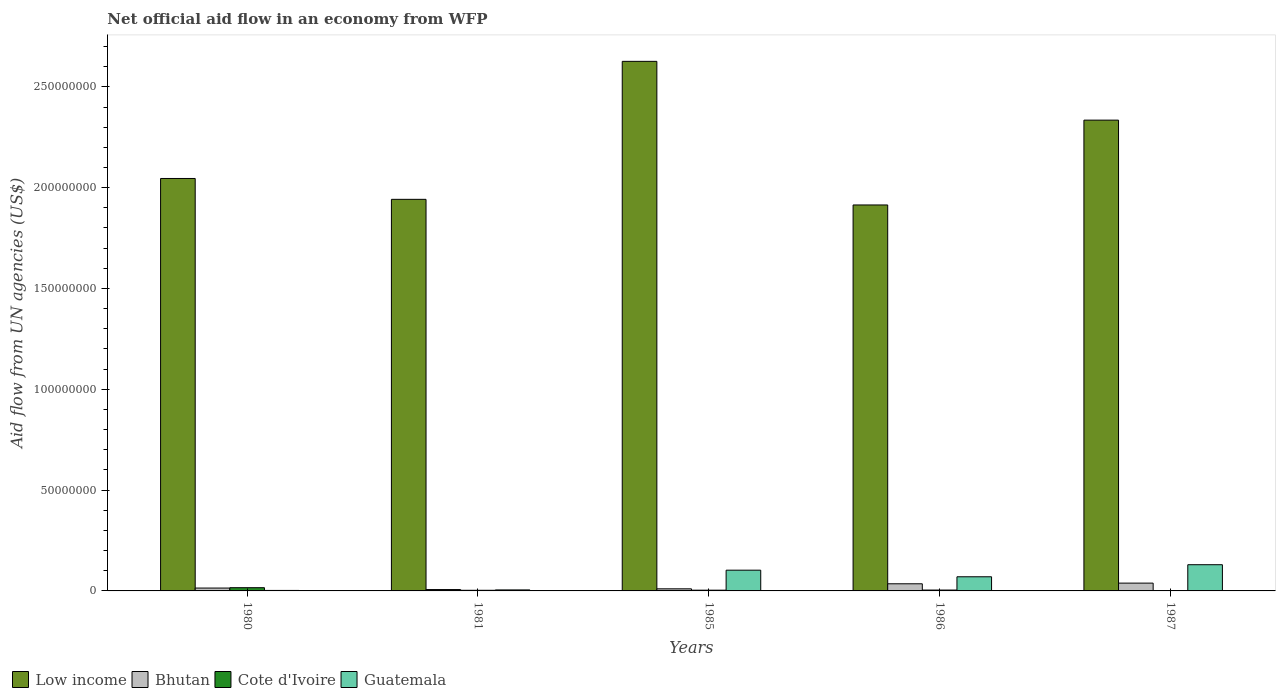Are the number of bars per tick equal to the number of legend labels?
Ensure brevity in your answer.  Yes. Are the number of bars on each tick of the X-axis equal?
Ensure brevity in your answer.  Yes. How many bars are there on the 5th tick from the left?
Your answer should be compact. 4. In how many cases, is the number of bars for a given year not equal to the number of legend labels?
Make the answer very short. 0. What is the net official aid flow in Guatemala in 1985?
Ensure brevity in your answer.  1.03e+07. Across all years, what is the maximum net official aid flow in Bhutan?
Make the answer very short. 3.87e+06. Across all years, what is the minimum net official aid flow in Bhutan?
Your response must be concise. 6.80e+05. In which year was the net official aid flow in Bhutan maximum?
Keep it short and to the point. 1987. In which year was the net official aid flow in Bhutan minimum?
Make the answer very short. 1981. What is the total net official aid flow in Low income in the graph?
Provide a succinct answer. 1.09e+09. What is the difference between the net official aid flow in Guatemala in 1986 and that in 1987?
Provide a short and direct response. -5.98e+06. What is the difference between the net official aid flow in Guatemala in 1981 and the net official aid flow in Bhutan in 1980?
Give a very brief answer. -9.20e+05. What is the average net official aid flow in Cote d'Ivoire per year?
Offer a terse response. 5.54e+05. In the year 1981, what is the difference between the net official aid flow in Guatemala and net official aid flow in Cote d'Ivoire?
Ensure brevity in your answer.  1.90e+05. What is the ratio of the net official aid flow in Cote d'Ivoire in 1980 to that in 1981?
Your answer should be compact. 5.16. Is the difference between the net official aid flow in Guatemala in 1986 and 1987 greater than the difference between the net official aid flow in Cote d'Ivoire in 1986 and 1987?
Make the answer very short. No. What is the difference between the highest and the second highest net official aid flow in Bhutan?
Offer a terse response. 3.30e+05. What is the difference between the highest and the lowest net official aid flow in Low income?
Make the answer very short. 7.12e+07. In how many years, is the net official aid flow in Bhutan greater than the average net official aid flow in Bhutan taken over all years?
Keep it short and to the point. 2. Is the sum of the net official aid flow in Cote d'Ivoire in 1985 and 1986 greater than the maximum net official aid flow in Bhutan across all years?
Provide a short and direct response. No. What does the 2nd bar from the left in 1986 represents?
Your response must be concise. Bhutan. What does the 1st bar from the right in 1980 represents?
Your answer should be very brief. Guatemala. Is it the case that in every year, the sum of the net official aid flow in Bhutan and net official aid flow in Guatemala is greater than the net official aid flow in Low income?
Your response must be concise. No. How many bars are there?
Your response must be concise. 20. Are all the bars in the graph horizontal?
Your answer should be compact. No. Does the graph contain any zero values?
Make the answer very short. No. What is the title of the graph?
Your response must be concise. Net official aid flow in an economy from WFP. Does "Isle of Man" appear as one of the legend labels in the graph?
Make the answer very short. No. What is the label or title of the X-axis?
Your answer should be compact. Years. What is the label or title of the Y-axis?
Your response must be concise. Aid flow from UN agencies (US$). What is the Aid flow from UN agencies (US$) in Low income in 1980?
Make the answer very short. 2.05e+08. What is the Aid flow from UN agencies (US$) in Bhutan in 1980?
Keep it short and to the point. 1.42e+06. What is the Aid flow from UN agencies (US$) in Cote d'Ivoire in 1980?
Provide a short and direct response. 1.60e+06. What is the Aid flow from UN agencies (US$) in Guatemala in 1980?
Ensure brevity in your answer.  2.40e+05. What is the Aid flow from UN agencies (US$) in Low income in 1981?
Provide a short and direct response. 1.94e+08. What is the Aid flow from UN agencies (US$) in Bhutan in 1981?
Offer a very short reply. 6.80e+05. What is the Aid flow from UN agencies (US$) of Cote d'Ivoire in 1981?
Give a very brief answer. 3.10e+05. What is the Aid flow from UN agencies (US$) of Low income in 1985?
Make the answer very short. 2.63e+08. What is the Aid flow from UN agencies (US$) of Bhutan in 1985?
Offer a terse response. 1.04e+06. What is the Aid flow from UN agencies (US$) in Cote d'Ivoire in 1985?
Make the answer very short. 3.70e+05. What is the Aid flow from UN agencies (US$) in Guatemala in 1985?
Keep it short and to the point. 1.03e+07. What is the Aid flow from UN agencies (US$) of Low income in 1986?
Ensure brevity in your answer.  1.91e+08. What is the Aid flow from UN agencies (US$) of Bhutan in 1986?
Your answer should be compact. 3.54e+06. What is the Aid flow from UN agencies (US$) in Guatemala in 1986?
Your response must be concise. 7.02e+06. What is the Aid flow from UN agencies (US$) in Low income in 1987?
Give a very brief answer. 2.33e+08. What is the Aid flow from UN agencies (US$) of Bhutan in 1987?
Provide a succinct answer. 3.87e+06. What is the Aid flow from UN agencies (US$) of Cote d'Ivoire in 1987?
Offer a terse response. 6.00e+04. What is the Aid flow from UN agencies (US$) in Guatemala in 1987?
Offer a very short reply. 1.30e+07. Across all years, what is the maximum Aid flow from UN agencies (US$) in Low income?
Your answer should be compact. 2.63e+08. Across all years, what is the maximum Aid flow from UN agencies (US$) in Bhutan?
Provide a succinct answer. 3.87e+06. Across all years, what is the maximum Aid flow from UN agencies (US$) in Cote d'Ivoire?
Offer a terse response. 1.60e+06. Across all years, what is the maximum Aid flow from UN agencies (US$) in Guatemala?
Ensure brevity in your answer.  1.30e+07. Across all years, what is the minimum Aid flow from UN agencies (US$) of Low income?
Give a very brief answer. 1.91e+08. Across all years, what is the minimum Aid flow from UN agencies (US$) in Bhutan?
Ensure brevity in your answer.  6.80e+05. What is the total Aid flow from UN agencies (US$) of Low income in the graph?
Give a very brief answer. 1.09e+09. What is the total Aid flow from UN agencies (US$) of Bhutan in the graph?
Your response must be concise. 1.06e+07. What is the total Aid flow from UN agencies (US$) of Cote d'Ivoire in the graph?
Offer a terse response. 2.77e+06. What is the total Aid flow from UN agencies (US$) in Guatemala in the graph?
Give a very brief answer. 3.10e+07. What is the difference between the Aid flow from UN agencies (US$) in Low income in 1980 and that in 1981?
Give a very brief answer. 1.03e+07. What is the difference between the Aid flow from UN agencies (US$) of Bhutan in 1980 and that in 1981?
Ensure brevity in your answer.  7.40e+05. What is the difference between the Aid flow from UN agencies (US$) of Cote d'Ivoire in 1980 and that in 1981?
Keep it short and to the point. 1.29e+06. What is the difference between the Aid flow from UN agencies (US$) of Low income in 1980 and that in 1985?
Give a very brief answer. -5.81e+07. What is the difference between the Aid flow from UN agencies (US$) of Cote d'Ivoire in 1980 and that in 1985?
Your answer should be very brief. 1.23e+06. What is the difference between the Aid flow from UN agencies (US$) in Guatemala in 1980 and that in 1985?
Offer a very short reply. -1.00e+07. What is the difference between the Aid flow from UN agencies (US$) in Low income in 1980 and that in 1986?
Your answer should be compact. 1.31e+07. What is the difference between the Aid flow from UN agencies (US$) of Bhutan in 1980 and that in 1986?
Provide a succinct answer. -2.12e+06. What is the difference between the Aid flow from UN agencies (US$) in Cote d'Ivoire in 1980 and that in 1986?
Make the answer very short. 1.17e+06. What is the difference between the Aid flow from UN agencies (US$) in Guatemala in 1980 and that in 1986?
Your response must be concise. -6.78e+06. What is the difference between the Aid flow from UN agencies (US$) of Low income in 1980 and that in 1987?
Your response must be concise. -2.89e+07. What is the difference between the Aid flow from UN agencies (US$) in Bhutan in 1980 and that in 1987?
Your answer should be very brief. -2.45e+06. What is the difference between the Aid flow from UN agencies (US$) of Cote d'Ivoire in 1980 and that in 1987?
Give a very brief answer. 1.54e+06. What is the difference between the Aid flow from UN agencies (US$) in Guatemala in 1980 and that in 1987?
Offer a very short reply. -1.28e+07. What is the difference between the Aid flow from UN agencies (US$) of Low income in 1981 and that in 1985?
Give a very brief answer. -6.84e+07. What is the difference between the Aid flow from UN agencies (US$) in Bhutan in 1981 and that in 1985?
Make the answer very short. -3.60e+05. What is the difference between the Aid flow from UN agencies (US$) of Guatemala in 1981 and that in 1985?
Keep it short and to the point. -9.79e+06. What is the difference between the Aid flow from UN agencies (US$) of Low income in 1981 and that in 1986?
Keep it short and to the point. 2.79e+06. What is the difference between the Aid flow from UN agencies (US$) in Bhutan in 1981 and that in 1986?
Provide a succinct answer. -2.86e+06. What is the difference between the Aid flow from UN agencies (US$) in Guatemala in 1981 and that in 1986?
Make the answer very short. -6.52e+06. What is the difference between the Aid flow from UN agencies (US$) of Low income in 1981 and that in 1987?
Give a very brief answer. -3.93e+07. What is the difference between the Aid flow from UN agencies (US$) of Bhutan in 1981 and that in 1987?
Your answer should be very brief. -3.19e+06. What is the difference between the Aid flow from UN agencies (US$) of Cote d'Ivoire in 1981 and that in 1987?
Give a very brief answer. 2.50e+05. What is the difference between the Aid flow from UN agencies (US$) in Guatemala in 1981 and that in 1987?
Ensure brevity in your answer.  -1.25e+07. What is the difference between the Aid flow from UN agencies (US$) in Low income in 1985 and that in 1986?
Give a very brief answer. 7.12e+07. What is the difference between the Aid flow from UN agencies (US$) in Bhutan in 1985 and that in 1986?
Offer a terse response. -2.50e+06. What is the difference between the Aid flow from UN agencies (US$) of Guatemala in 1985 and that in 1986?
Provide a succinct answer. 3.27e+06. What is the difference between the Aid flow from UN agencies (US$) of Low income in 1985 and that in 1987?
Ensure brevity in your answer.  2.92e+07. What is the difference between the Aid flow from UN agencies (US$) in Bhutan in 1985 and that in 1987?
Give a very brief answer. -2.83e+06. What is the difference between the Aid flow from UN agencies (US$) of Guatemala in 1985 and that in 1987?
Your response must be concise. -2.71e+06. What is the difference between the Aid flow from UN agencies (US$) in Low income in 1986 and that in 1987?
Offer a terse response. -4.21e+07. What is the difference between the Aid flow from UN agencies (US$) in Bhutan in 1986 and that in 1987?
Provide a short and direct response. -3.30e+05. What is the difference between the Aid flow from UN agencies (US$) in Guatemala in 1986 and that in 1987?
Provide a succinct answer. -5.98e+06. What is the difference between the Aid flow from UN agencies (US$) of Low income in 1980 and the Aid flow from UN agencies (US$) of Bhutan in 1981?
Make the answer very short. 2.04e+08. What is the difference between the Aid flow from UN agencies (US$) in Low income in 1980 and the Aid flow from UN agencies (US$) in Cote d'Ivoire in 1981?
Offer a terse response. 2.04e+08. What is the difference between the Aid flow from UN agencies (US$) of Low income in 1980 and the Aid flow from UN agencies (US$) of Guatemala in 1981?
Give a very brief answer. 2.04e+08. What is the difference between the Aid flow from UN agencies (US$) of Bhutan in 1980 and the Aid flow from UN agencies (US$) of Cote d'Ivoire in 1981?
Your answer should be compact. 1.11e+06. What is the difference between the Aid flow from UN agencies (US$) in Bhutan in 1980 and the Aid flow from UN agencies (US$) in Guatemala in 1981?
Provide a succinct answer. 9.20e+05. What is the difference between the Aid flow from UN agencies (US$) in Cote d'Ivoire in 1980 and the Aid flow from UN agencies (US$) in Guatemala in 1981?
Your answer should be very brief. 1.10e+06. What is the difference between the Aid flow from UN agencies (US$) of Low income in 1980 and the Aid flow from UN agencies (US$) of Bhutan in 1985?
Make the answer very short. 2.04e+08. What is the difference between the Aid flow from UN agencies (US$) in Low income in 1980 and the Aid flow from UN agencies (US$) in Cote d'Ivoire in 1985?
Provide a short and direct response. 2.04e+08. What is the difference between the Aid flow from UN agencies (US$) of Low income in 1980 and the Aid flow from UN agencies (US$) of Guatemala in 1985?
Offer a terse response. 1.94e+08. What is the difference between the Aid flow from UN agencies (US$) of Bhutan in 1980 and the Aid flow from UN agencies (US$) of Cote d'Ivoire in 1985?
Give a very brief answer. 1.05e+06. What is the difference between the Aid flow from UN agencies (US$) of Bhutan in 1980 and the Aid flow from UN agencies (US$) of Guatemala in 1985?
Offer a terse response. -8.87e+06. What is the difference between the Aid flow from UN agencies (US$) of Cote d'Ivoire in 1980 and the Aid flow from UN agencies (US$) of Guatemala in 1985?
Your response must be concise. -8.69e+06. What is the difference between the Aid flow from UN agencies (US$) in Low income in 1980 and the Aid flow from UN agencies (US$) in Bhutan in 1986?
Your response must be concise. 2.01e+08. What is the difference between the Aid flow from UN agencies (US$) in Low income in 1980 and the Aid flow from UN agencies (US$) in Cote d'Ivoire in 1986?
Offer a very short reply. 2.04e+08. What is the difference between the Aid flow from UN agencies (US$) in Low income in 1980 and the Aid flow from UN agencies (US$) in Guatemala in 1986?
Offer a terse response. 1.98e+08. What is the difference between the Aid flow from UN agencies (US$) in Bhutan in 1980 and the Aid flow from UN agencies (US$) in Cote d'Ivoire in 1986?
Your response must be concise. 9.90e+05. What is the difference between the Aid flow from UN agencies (US$) of Bhutan in 1980 and the Aid flow from UN agencies (US$) of Guatemala in 1986?
Provide a succinct answer. -5.60e+06. What is the difference between the Aid flow from UN agencies (US$) in Cote d'Ivoire in 1980 and the Aid flow from UN agencies (US$) in Guatemala in 1986?
Provide a short and direct response. -5.42e+06. What is the difference between the Aid flow from UN agencies (US$) of Low income in 1980 and the Aid flow from UN agencies (US$) of Bhutan in 1987?
Provide a succinct answer. 2.01e+08. What is the difference between the Aid flow from UN agencies (US$) in Low income in 1980 and the Aid flow from UN agencies (US$) in Cote d'Ivoire in 1987?
Offer a very short reply. 2.04e+08. What is the difference between the Aid flow from UN agencies (US$) in Low income in 1980 and the Aid flow from UN agencies (US$) in Guatemala in 1987?
Ensure brevity in your answer.  1.92e+08. What is the difference between the Aid flow from UN agencies (US$) in Bhutan in 1980 and the Aid flow from UN agencies (US$) in Cote d'Ivoire in 1987?
Offer a terse response. 1.36e+06. What is the difference between the Aid flow from UN agencies (US$) in Bhutan in 1980 and the Aid flow from UN agencies (US$) in Guatemala in 1987?
Make the answer very short. -1.16e+07. What is the difference between the Aid flow from UN agencies (US$) of Cote d'Ivoire in 1980 and the Aid flow from UN agencies (US$) of Guatemala in 1987?
Make the answer very short. -1.14e+07. What is the difference between the Aid flow from UN agencies (US$) of Low income in 1981 and the Aid flow from UN agencies (US$) of Bhutan in 1985?
Make the answer very short. 1.93e+08. What is the difference between the Aid flow from UN agencies (US$) in Low income in 1981 and the Aid flow from UN agencies (US$) in Cote d'Ivoire in 1985?
Offer a very short reply. 1.94e+08. What is the difference between the Aid flow from UN agencies (US$) of Low income in 1981 and the Aid flow from UN agencies (US$) of Guatemala in 1985?
Make the answer very short. 1.84e+08. What is the difference between the Aid flow from UN agencies (US$) of Bhutan in 1981 and the Aid flow from UN agencies (US$) of Guatemala in 1985?
Your answer should be compact. -9.61e+06. What is the difference between the Aid flow from UN agencies (US$) of Cote d'Ivoire in 1981 and the Aid flow from UN agencies (US$) of Guatemala in 1985?
Your response must be concise. -9.98e+06. What is the difference between the Aid flow from UN agencies (US$) in Low income in 1981 and the Aid flow from UN agencies (US$) in Bhutan in 1986?
Ensure brevity in your answer.  1.91e+08. What is the difference between the Aid flow from UN agencies (US$) in Low income in 1981 and the Aid flow from UN agencies (US$) in Cote d'Ivoire in 1986?
Make the answer very short. 1.94e+08. What is the difference between the Aid flow from UN agencies (US$) of Low income in 1981 and the Aid flow from UN agencies (US$) of Guatemala in 1986?
Provide a succinct answer. 1.87e+08. What is the difference between the Aid flow from UN agencies (US$) of Bhutan in 1981 and the Aid flow from UN agencies (US$) of Cote d'Ivoire in 1986?
Ensure brevity in your answer.  2.50e+05. What is the difference between the Aid flow from UN agencies (US$) in Bhutan in 1981 and the Aid flow from UN agencies (US$) in Guatemala in 1986?
Provide a succinct answer. -6.34e+06. What is the difference between the Aid flow from UN agencies (US$) in Cote d'Ivoire in 1981 and the Aid flow from UN agencies (US$) in Guatemala in 1986?
Offer a very short reply. -6.71e+06. What is the difference between the Aid flow from UN agencies (US$) in Low income in 1981 and the Aid flow from UN agencies (US$) in Bhutan in 1987?
Your answer should be very brief. 1.90e+08. What is the difference between the Aid flow from UN agencies (US$) in Low income in 1981 and the Aid flow from UN agencies (US$) in Cote d'Ivoire in 1987?
Provide a short and direct response. 1.94e+08. What is the difference between the Aid flow from UN agencies (US$) of Low income in 1981 and the Aid flow from UN agencies (US$) of Guatemala in 1987?
Your answer should be compact. 1.81e+08. What is the difference between the Aid flow from UN agencies (US$) of Bhutan in 1981 and the Aid flow from UN agencies (US$) of Cote d'Ivoire in 1987?
Your answer should be compact. 6.20e+05. What is the difference between the Aid flow from UN agencies (US$) in Bhutan in 1981 and the Aid flow from UN agencies (US$) in Guatemala in 1987?
Offer a terse response. -1.23e+07. What is the difference between the Aid flow from UN agencies (US$) in Cote d'Ivoire in 1981 and the Aid flow from UN agencies (US$) in Guatemala in 1987?
Your answer should be compact. -1.27e+07. What is the difference between the Aid flow from UN agencies (US$) in Low income in 1985 and the Aid flow from UN agencies (US$) in Bhutan in 1986?
Your answer should be very brief. 2.59e+08. What is the difference between the Aid flow from UN agencies (US$) in Low income in 1985 and the Aid flow from UN agencies (US$) in Cote d'Ivoire in 1986?
Ensure brevity in your answer.  2.62e+08. What is the difference between the Aid flow from UN agencies (US$) of Low income in 1985 and the Aid flow from UN agencies (US$) of Guatemala in 1986?
Give a very brief answer. 2.56e+08. What is the difference between the Aid flow from UN agencies (US$) of Bhutan in 1985 and the Aid flow from UN agencies (US$) of Cote d'Ivoire in 1986?
Make the answer very short. 6.10e+05. What is the difference between the Aid flow from UN agencies (US$) in Bhutan in 1985 and the Aid flow from UN agencies (US$) in Guatemala in 1986?
Your answer should be very brief. -5.98e+06. What is the difference between the Aid flow from UN agencies (US$) of Cote d'Ivoire in 1985 and the Aid flow from UN agencies (US$) of Guatemala in 1986?
Provide a succinct answer. -6.65e+06. What is the difference between the Aid flow from UN agencies (US$) of Low income in 1985 and the Aid flow from UN agencies (US$) of Bhutan in 1987?
Provide a succinct answer. 2.59e+08. What is the difference between the Aid flow from UN agencies (US$) in Low income in 1985 and the Aid flow from UN agencies (US$) in Cote d'Ivoire in 1987?
Your answer should be very brief. 2.63e+08. What is the difference between the Aid flow from UN agencies (US$) in Low income in 1985 and the Aid flow from UN agencies (US$) in Guatemala in 1987?
Your answer should be compact. 2.50e+08. What is the difference between the Aid flow from UN agencies (US$) in Bhutan in 1985 and the Aid flow from UN agencies (US$) in Cote d'Ivoire in 1987?
Offer a very short reply. 9.80e+05. What is the difference between the Aid flow from UN agencies (US$) of Bhutan in 1985 and the Aid flow from UN agencies (US$) of Guatemala in 1987?
Give a very brief answer. -1.20e+07. What is the difference between the Aid flow from UN agencies (US$) of Cote d'Ivoire in 1985 and the Aid flow from UN agencies (US$) of Guatemala in 1987?
Provide a succinct answer. -1.26e+07. What is the difference between the Aid flow from UN agencies (US$) of Low income in 1986 and the Aid flow from UN agencies (US$) of Bhutan in 1987?
Offer a very short reply. 1.88e+08. What is the difference between the Aid flow from UN agencies (US$) in Low income in 1986 and the Aid flow from UN agencies (US$) in Cote d'Ivoire in 1987?
Make the answer very short. 1.91e+08. What is the difference between the Aid flow from UN agencies (US$) of Low income in 1986 and the Aid flow from UN agencies (US$) of Guatemala in 1987?
Give a very brief answer. 1.78e+08. What is the difference between the Aid flow from UN agencies (US$) in Bhutan in 1986 and the Aid flow from UN agencies (US$) in Cote d'Ivoire in 1987?
Keep it short and to the point. 3.48e+06. What is the difference between the Aid flow from UN agencies (US$) of Bhutan in 1986 and the Aid flow from UN agencies (US$) of Guatemala in 1987?
Provide a succinct answer. -9.46e+06. What is the difference between the Aid flow from UN agencies (US$) of Cote d'Ivoire in 1986 and the Aid flow from UN agencies (US$) of Guatemala in 1987?
Give a very brief answer. -1.26e+07. What is the average Aid flow from UN agencies (US$) of Low income per year?
Offer a very short reply. 2.17e+08. What is the average Aid flow from UN agencies (US$) in Bhutan per year?
Give a very brief answer. 2.11e+06. What is the average Aid flow from UN agencies (US$) in Cote d'Ivoire per year?
Give a very brief answer. 5.54e+05. What is the average Aid flow from UN agencies (US$) of Guatemala per year?
Give a very brief answer. 6.21e+06. In the year 1980, what is the difference between the Aid flow from UN agencies (US$) in Low income and Aid flow from UN agencies (US$) in Bhutan?
Give a very brief answer. 2.03e+08. In the year 1980, what is the difference between the Aid flow from UN agencies (US$) of Low income and Aid flow from UN agencies (US$) of Cote d'Ivoire?
Offer a terse response. 2.03e+08. In the year 1980, what is the difference between the Aid flow from UN agencies (US$) of Low income and Aid flow from UN agencies (US$) of Guatemala?
Make the answer very short. 2.04e+08. In the year 1980, what is the difference between the Aid flow from UN agencies (US$) of Bhutan and Aid flow from UN agencies (US$) of Cote d'Ivoire?
Offer a terse response. -1.80e+05. In the year 1980, what is the difference between the Aid flow from UN agencies (US$) in Bhutan and Aid flow from UN agencies (US$) in Guatemala?
Provide a short and direct response. 1.18e+06. In the year 1980, what is the difference between the Aid flow from UN agencies (US$) of Cote d'Ivoire and Aid flow from UN agencies (US$) of Guatemala?
Your answer should be compact. 1.36e+06. In the year 1981, what is the difference between the Aid flow from UN agencies (US$) in Low income and Aid flow from UN agencies (US$) in Bhutan?
Provide a short and direct response. 1.94e+08. In the year 1981, what is the difference between the Aid flow from UN agencies (US$) of Low income and Aid flow from UN agencies (US$) of Cote d'Ivoire?
Your answer should be compact. 1.94e+08. In the year 1981, what is the difference between the Aid flow from UN agencies (US$) of Low income and Aid flow from UN agencies (US$) of Guatemala?
Provide a short and direct response. 1.94e+08. In the year 1981, what is the difference between the Aid flow from UN agencies (US$) in Bhutan and Aid flow from UN agencies (US$) in Guatemala?
Provide a succinct answer. 1.80e+05. In the year 1981, what is the difference between the Aid flow from UN agencies (US$) of Cote d'Ivoire and Aid flow from UN agencies (US$) of Guatemala?
Your answer should be compact. -1.90e+05. In the year 1985, what is the difference between the Aid flow from UN agencies (US$) in Low income and Aid flow from UN agencies (US$) in Bhutan?
Offer a terse response. 2.62e+08. In the year 1985, what is the difference between the Aid flow from UN agencies (US$) of Low income and Aid flow from UN agencies (US$) of Cote d'Ivoire?
Ensure brevity in your answer.  2.62e+08. In the year 1985, what is the difference between the Aid flow from UN agencies (US$) in Low income and Aid flow from UN agencies (US$) in Guatemala?
Keep it short and to the point. 2.52e+08. In the year 1985, what is the difference between the Aid flow from UN agencies (US$) of Bhutan and Aid flow from UN agencies (US$) of Cote d'Ivoire?
Your answer should be compact. 6.70e+05. In the year 1985, what is the difference between the Aid flow from UN agencies (US$) of Bhutan and Aid flow from UN agencies (US$) of Guatemala?
Ensure brevity in your answer.  -9.25e+06. In the year 1985, what is the difference between the Aid flow from UN agencies (US$) in Cote d'Ivoire and Aid flow from UN agencies (US$) in Guatemala?
Make the answer very short. -9.92e+06. In the year 1986, what is the difference between the Aid flow from UN agencies (US$) of Low income and Aid flow from UN agencies (US$) of Bhutan?
Your answer should be compact. 1.88e+08. In the year 1986, what is the difference between the Aid flow from UN agencies (US$) of Low income and Aid flow from UN agencies (US$) of Cote d'Ivoire?
Your answer should be compact. 1.91e+08. In the year 1986, what is the difference between the Aid flow from UN agencies (US$) of Low income and Aid flow from UN agencies (US$) of Guatemala?
Make the answer very short. 1.84e+08. In the year 1986, what is the difference between the Aid flow from UN agencies (US$) of Bhutan and Aid flow from UN agencies (US$) of Cote d'Ivoire?
Provide a succinct answer. 3.11e+06. In the year 1986, what is the difference between the Aid flow from UN agencies (US$) of Bhutan and Aid flow from UN agencies (US$) of Guatemala?
Make the answer very short. -3.48e+06. In the year 1986, what is the difference between the Aid flow from UN agencies (US$) of Cote d'Ivoire and Aid flow from UN agencies (US$) of Guatemala?
Make the answer very short. -6.59e+06. In the year 1987, what is the difference between the Aid flow from UN agencies (US$) of Low income and Aid flow from UN agencies (US$) of Bhutan?
Your answer should be very brief. 2.30e+08. In the year 1987, what is the difference between the Aid flow from UN agencies (US$) in Low income and Aid flow from UN agencies (US$) in Cote d'Ivoire?
Give a very brief answer. 2.33e+08. In the year 1987, what is the difference between the Aid flow from UN agencies (US$) in Low income and Aid flow from UN agencies (US$) in Guatemala?
Your answer should be compact. 2.20e+08. In the year 1987, what is the difference between the Aid flow from UN agencies (US$) of Bhutan and Aid flow from UN agencies (US$) of Cote d'Ivoire?
Give a very brief answer. 3.81e+06. In the year 1987, what is the difference between the Aid flow from UN agencies (US$) of Bhutan and Aid flow from UN agencies (US$) of Guatemala?
Make the answer very short. -9.13e+06. In the year 1987, what is the difference between the Aid flow from UN agencies (US$) of Cote d'Ivoire and Aid flow from UN agencies (US$) of Guatemala?
Offer a very short reply. -1.29e+07. What is the ratio of the Aid flow from UN agencies (US$) of Low income in 1980 to that in 1981?
Offer a very short reply. 1.05. What is the ratio of the Aid flow from UN agencies (US$) in Bhutan in 1980 to that in 1981?
Make the answer very short. 2.09. What is the ratio of the Aid flow from UN agencies (US$) of Cote d'Ivoire in 1980 to that in 1981?
Make the answer very short. 5.16. What is the ratio of the Aid flow from UN agencies (US$) in Guatemala in 1980 to that in 1981?
Your response must be concise. 0.48. What is the ratio of the Aid flow from UN agencies (US$) in Low income in 1980 to that in 1985?
Your answer should be very brief. 0.78. What is the ratio of the Aid flow from UN agencies (US$) of Bhutan in 1980 to that in 1985?
Provide a short and direct response. 1.37. What is the ratio of the Aid flow from UN agencies (US$) of Cote d'Ivoire in 1980 to that in 1985?
Provide a succinct answer. 4.32. What is the ratio of the Aid flow from UN agencies (US$) of Guatemala in 1980 to that in 1985?
Ensure brevity in your answer.  0.02. What is the ratio of the Aid flow from UN agencies (US$) of Low income in 1980 to that in 1986?
Provide a succinct answer. 1.07. What is the ratio of the Aid flow from UN agencies (US$) in Bhutan in 1980 to that in 1986?
Make the answer very short. 0.4. What is the ratio of the Aid flow from UN agencies (US$) of Cote d'Ivoire in 1980 to that in 1986?
Your response must be concise. 3.72. What is the ratio of the Aid flow from UN agencies (US$) of Guatemala in 1980 to that in 1986?
Make the answer very short. 0.03. What is the ratio of the Aid flow from UN agencies (US$) of Low income in 1980 to that in 1987?
Keep it short and to the point. 0.88. What is the ratio of the Aid flow from UN agencies (US$) of Bhutan in 1980 to that in 1987?
Provide a succinct answer. 0.37. What is the ratio of the Aid flow from UN agencies (US$) of Cote d'Ivoire in 1980 to that in 1987?
Give a very brief answer. 26.67. What is the ratio of the Aid flow from UN agencies (US$) of Guatemala in 1980 to that in 1987?
Offer a terse response. 0.02. What is the ratio of the Aid flow from UN agencies (US$) of Low income in 1981 to that in 1985?
Your response must be concise. 0.74. What is the ratio of the Aid flow from UN agencies (US$) of Bhutan in 1981 to that in 1985?
Offer a very short reply. 0.65. What is the ratio of the Aid flow from UN agencies (US$) in Cote d'Ivoire in 1981 to that in 1985?
Give a very brief answer. 0.84. What is the ratio of the Aid flow from UN agencies (US$) of Guatemala in 1981 to that in 1985?
Keep it short and to the point. 0.05. What is the ratio of the Aid flow from UN agencies (US$) in Low income in 1981 to that in 1986?
Provide a short and direct response. 1.01. What is the ratio of the Aid flow from UN agencies (US$) in Bhutan in 1981 to that in 1986?
Your response must be concise. 0.19. What is the ratio of the Aid flow from UN agencies (US$) of Cote d'Ivoire in 1981 to that in 1986?
Provide a short and direct response. 0.72. What is the ratio of the Aid flow from UN agencies (US$) of Guatemala in 1981 to that in 1986?
Your answer should be very brief. 0.07. What is the ratio of the Aid flow from UN agencies (US$) of Low income in 1981 to that in 1987?
Give a very brief answer. 0.83. What is the ratio of the Aid flow from UN agencies (US$) in Bhutan in 1981 to that in 1987?
Your response must be concise. 0.18. What is the ratio of the Aid flow from UN agencies (US$) of Cote d'Ivoire in 1981 to that in 1987?
Provide a succinct answer. 5.17. What is the ratio of the Aid flow from UN agencies (US$) of Guatemala in 1981 to that in 1987?
Keep it short and to the point. 0.04. What is the ratio of the Aid flow from UN agencies (US$) in Low income in 1985 to that in 1986?
Ensure brevity in your answer.  1.37. What is the ratio of the Aid flow from UN agencies (US$) in Bhutan in 1985 to that in 1986?
Keep it short and to the point. 0.29. What is the ratio of the Aid flow from UN agencies (US$) in Cote d'Ivoire in 1985 to that in 1986?
Your answer should be compact. 0.86. What is the ratio of the Aid flow from UN agencies (US$) of Guatemala in 1985 to that in 1986?
Provide a short and direct response. 1.47. What is the ratio of the Aid flow from UN agencies (US$) of Low income in 1985 to that in 1987?
Your answer should be compact. 1.12. What is the ratio of the Aid flow from UN agencies (US$) in Bhutan in 1985 to that in 1987?
Offer a very short reply. 0.27. What is the ratio of the Aid flow from UN agencies (US$) of Cote d'Ivoire in 1985 to that in 1987?
Ensure brevity in your answer.  6.17. What is the ratio of the Aid flow from UN agencies (US$) of Guatemala in 1985 to that in 1987?
Give a very brief answer. 0.79. What is the ratio of the Aid flow from UN agencies (US$) of Low income in 1986 to that in 1987?
Your answer should be compact. 0.82. What is the ratio of the Aid flow from UN agencies (US$) in Bhutan in 1986 to that in 1987?
Keep it short and to the point. 0.91. What is the ratio of the Aid flow from UN agencies (US$) in Cote d'Ivoire in 1986 to that in 1987?
Offer a very short reply. 7.17. What is the ratio of the Aid flow from UN agencies (US$) in Guatemala in 1986 to that in 1987?
Your answer should be compact. 0.54. What is the difference between the highest and the second highest Aid flow from UN agencies (US$) of Low income?
Your response must be concise. 2.92e+07. What is the difference between the highest and the second highest Aid flow from UN agencies (US$) of Bhutan?
Offer a very short reply. 3.30e+05. What is the difference between the highest and the second highest Aid flow from UN agencies (US$) in Cote d'Ivoire?
Provide a short and direct response. 1.17e+06. What is the difference between the highest and the second highest Aid flow from UN agencies (US$) in Guatemala?
Provide a succinct answer. 2.71e+06. What is the difference between the highest and the lowest Aid flow from UN agencies (US$) of Low income?
Keep it short and to the point. 7.12e+07. What is the difference between the highest and the lowest Aid flow from UN agencies (US$) of Bhutan?
Make the answer very short. 3.19e+06. What is the difference between the highest and the lowest Aid flow from UN agencies (US$) of Cote d'Ivoire?
Make the answer very short. 1.54e+06. What is the difference between the highest and the lowest Aid flow from UN agencies (US$) in Guatemala?
Keep it short and to the point. 1.28e+07. 